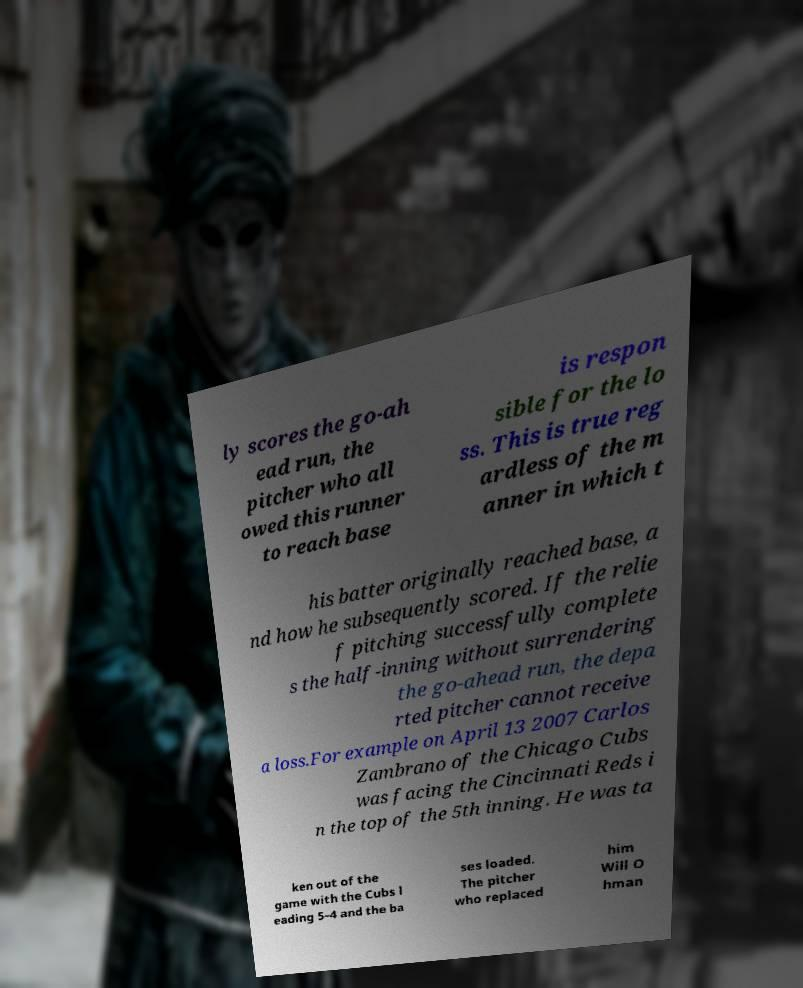What messages or text are displayed in this image? I need them in a readable, typed format. ly scores the go-ah ead run, the pitcher who all owed this runner to reach base is respon sible for the lo ss. This is true reg ardless of the m anner in which t his batter originally reached base, a nd how he subsequently scored. If the relie f pitching successfully complete s the half-inning without surrendering the go-ahead run, the depa rted pitcher cannot receive a loss.For example on April 13 2007 Carlos Zambrano of the Chicago Cubs was facing the Cincinnati Reds i n the top of the 5th inning. He was ta ken out of the game with the Cubs l eading 5–4 and the ba ses loaded. The pitcher who replaced him Will O hman 